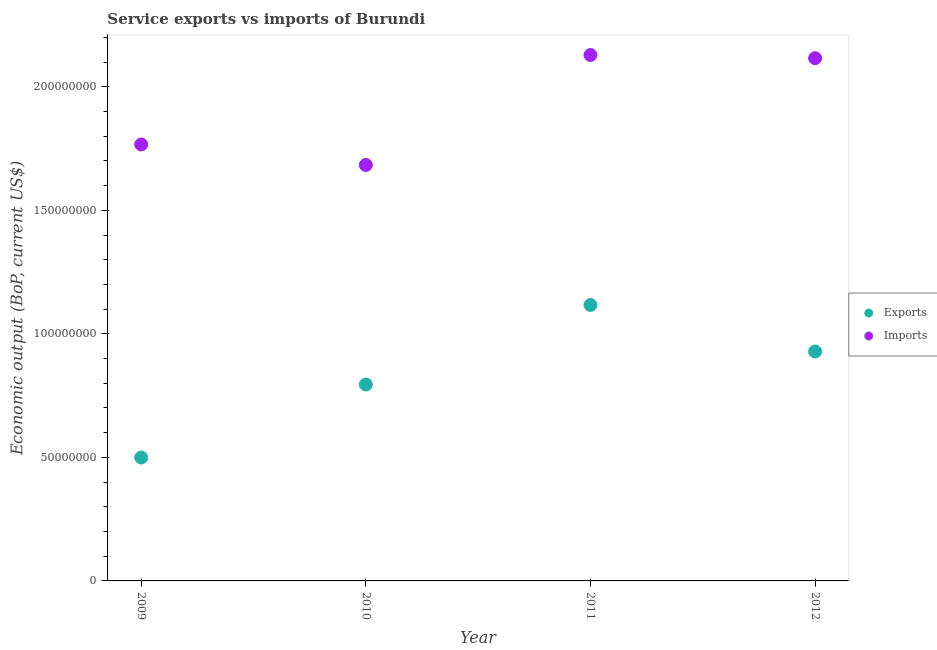How many different coloured dotlines are there?
Your answer should be very brief. 2. Is the number of dotlines equal to the number of legend labels?
Give a very brief answer. Yes. What is the amount of service imports in 2011?
Your answer should be very brief. 2.13e+08. Across all years, what is the maximum amount of service exports?
Your response must be concise. 1.12e+08. Across all years, what is the minimum amount of service imports?
Provide a short and direct response. 1.68e+08. In which year was the amount of service imports maximum?
Keep it short and to the point. 2011. What is the total amount of service imports in the graph?
Your response must be concise. 7.69e+08. What is the difference between the amount of service exports in 2010 and that in 2012?
Your answer should be compact. -1.33e+07. What is the difference between the amount of service exports in 2011 and the amount of service imports in 2012?
Offer a terse response. -9.99e+07. What is the average amount of service exports per year?
Your response must be concise. 8.35e+07. In the year 2010, what is the difference between the amount of service imports and amount of service exports?
Your answer should be very brief. 8.89e+07. What is the ratio of the amount of service exports in 2010 to that in 2011?
Offer a very short reply. 0.71. Is the amount of service exports in 2009 less than that in 2012?
Keep it short and to the point. Yes. Is the difference between the amount of service imports in 2009 and 2010 greater than the difference between the amount of service exports in 2009 and 2010?
Give a very brief answer. Yes. What is the difference between the highest and the second highest amount of service imports?
Offer a very short reply. 1.27e+06. What is the difference between the highest and the lowest amount of service imports?
Your answer should be very brief. 4.45e+07. Does the amount of service imports monotonically increase over the years?
Provide a short and direct response. No. Is the amount of service exports strictly greater than the amount of service imports over the years?
Offer a terse response. No. How many years are there in the graph?
Provide a short and direct response. 4. What is the difference between two consecutive major ticks on the Y-axis?
Make the answer very short. 5.00e+07. Does the graph contain any zero values?
Your response must be concise. No. How are the legend labels stacked?
Make the answer very short. Vertical. What is the title of the graph?
Your response must be concise. Service exports vs imports of Burundi. What is the label or title of the Y-axis?
Your response must be concise. Economic output (BoP, current US$). What is the Economic output (BoP, current US$) in Exports in 2009?
Ensure brevity in your answer.  4.99e+07. What is the Economic output (BoP, current US$) of Imports in 2009?
Offer a very short reply. 1.77e+08. What is the Economic output (BoP, current US$) in Exports in 2010?
Give a very brief answer. 7.95e+07. What is the Economic output (BoP, current US$) of Imports in 2010?
Provide a succinct answer. 1.68e+08. What is the Economic output (BoP, current US$) of Exports in 2011?
Your answer should be very brief. 1.12e+08. What is the Economic output (BoP, current US$) in Imports in 2011?
Make the answer very short. 2.13e+08. What is the Economic output (BoP, current US$) in Exports in 2012?
Your answer should be very brief. 9.28e+07. What is the Economic output (BoP, current US$) of Imports in 2012?
Offer a terse response. 2.12e+08. Across all years, what is the maximum Economic output (BoP, current US$) of Exports?
Your response must be concise. 1.12e+08. Across all years, what is the maximum Economic output (BoP, current US$) in Imports?
Your answer should be very brief. 2.13e+08. Across all years, what is the minimum Economic output (BoP, current US$) in Exports?
Make the answer very short. 4.99e+07. Across all years, what is the minimum Economic output (BoP, current US$) of Imports?
Your response must be concise. 1.68e+08. What is the total Economic output (BoP, current US$) of Exports in the graph?
Provide a succinct answer. 3.34e+08. What is the total Economic output (BoP, current US$) of Imports in the graph?
Your answer should be compact. 7.69e+08. What is the difference between the Economic output (BoP, current US$) in Exports in 2009 and that in 2010?
Your answer should be very brief. -2.96e+07. What is the difference between the Economic output (BoP, current US$) in Imports in 2009 and that in 2010?
Provide a succinct answer. 8.29e+06. What is the difference between the Economic output (BoP, current US$) in Exports in 2009 and that in 2011?
Ensure brevity in your answer.  -6.18e+07. What is the difference between the Economic output (BoP, current US$) of Imports in 2009 and that in 2011?
Your answer should be very brief. -3.62e+07. What is the difference between the Economic output (BoP, current US$) in Exports in 2009 and that in 2012?
Your answer should be compact. -4.29e+07. What is the difference between the Economic output (BoP, current US$) of Imports in 2009 and that in 2012?
Your answer should be compact. -3.49e+07. What is the difference between the Economic output (BoP, current US$) in Exports in 2010 and that in 2011?
Give a very brief answer. -3.22e+07. What is the difference between the Economic output (BoP, current US$) in Imports in 2010 and that in 2011?
Keep it short and to the point. -4.45e+07. What is the difference between the Economic output (BoP, current US$) of Exports in 2010 and that in 2012?
Ensure brevity in your answer.  -1.33e+07. What is the difference between the Economic output (BoP, current US$) of Imports in 2010 and that in 2012?
Offer a very short reply. -4.32e+07. What is the difference between the Economic output (BoP, current US$) of Exports in 2011 and that in 2012?
Your response must be concise. 1.88e+07. What is the difference between the Economic output (BoP, current US$) of Imports in 2011 and that in 2012?
Offer a terse response. 1.27e+06. What is the difference between the Economic output (BoP, current US$) of Exports in 2009 and the Economic output (BoP, current US$) of Imports in 2010?
Provide a succinct answer. -1.18e+08. What is the difference between the Economic output (BoP, current US$) of Exports in 2009 and the Economic output (BoP, current US$) of Imports in 2011?
Offer a very short reply. -1.63e+08. What is the difference between the Economic output (BoP, current US$) in Exports in 2009 and the Economic output (BoP, current US$) in Imports in 2012?
Your answer should be compact. -1.62e+08. What is the difference between the Economic output (BoP, current US$) of Exports in 2010 and the Economic output (BoP, current US$) of Imports in 2011?
Keep it short and to the point. -1.33e+08. What is the difference between the Economic output (BoP, current US$) in Exports in 2010 and the Economic output (BoP, current US$) in Imports in 2012?
Keep it short and to the point. -1.32e+08. What is the difference between the Economic output (BoP, current US$) of Exports in 2011 and the Economic output (BoP, current US$) of Imports in 2012?
Make the answer very short. -9.99e+07. What is the average Economic output (BoP, current US$) of Exports per year?
Give a very brief answer. 8.35e+07. What is the average Economic output (BoP, current US$) of Imports per year?
Ensure brevity in your answer.  1.92e+08. In the year 2009, what is the difference between the Economic output (BoP, current US$) of Exports and Economic output (BoP, current US$) of Imports?
Ensure brevity in your answer.  -1.27e+08. In the year 2010, what is the difference between the Economic output (BoP, current US$) of Exports and Economic output (BoP, current US$) of Imports?
Make the answer very short. -8.89e+07. In the year 2011, what is the difference between the Economic output (BoP, current US$) in Exports and Economic output (BoP, current US$) in Imports?
Your answer should be compact. -1.01e+08. In the year 2012, what is the difference between the Economic output (BoP, current US$) of Exports and Economic output (BoP, current US$) of Imports?
Your answer should be very brief. -1.19e+08. What is the ratio of the Economic output (BoP, current US$) of Exports in 2009 to that in 2010?
Your answer should be very brief. 0.63. What is the ratio of the Economic output (BoP, current US$) in Imports in 2009 to that in 2010?
Your answer should be very brief. 1.05. What is the ratio of the Economic output (BoP, current US$) of Exports in 2009 to that in 2011?
Ensure brevity in your answer.  0.45. What is the ratio of the Economic output (BoP, current US$) in Imports in 2009 to that in 2011?
Offer a terse response. 0.83. What is the ratio of the Economic output (BoP, current US$) in Exports in 2009 to that in 2012?
Offer a terse response. 0.54. What is the ratio of the Economic output (BoP, current US$) in Imports in 2009 to that in 2012?
Offer a terse response. 0.83. What is the ratio of the Economic output (BoP, current US$) of Exports in 2010 to that in 2011?
Your answer should be compact. 0.71. What is the ratio of the Economic output (BoP, current US$) of Imports in 2010 to that in 2011?
Provide a succinct answer. 0.79. What is the ratio of the Economic output (BoP, current US$) in Exports in 2010 to that in 2012?
Keep it short and to the point. 0.86. What is the ratio of the Economic output (BoP, current US$) of Imports in 2010 to that in 2012?
Your response must be concise. 0.8. What is the ratio of the Economic output (BoP, current US$) of Exports in 2011 to that in 2012?
Ensure brevity in your answer.  1.2. What is the difference between the highest and the second highest Economic output (BoP, current US$) of Exports?
Your answer should be compact. 1.88e+07. What is the difference between the highest and the second highest Economic output (BoP, current US$) in Imports?
Your response must be concise. 1.27e+06. What is the difference between the highest and the lowest Economic output (BoP, current US$) in Exports?
Offer a terse response. 6.18e+07. What is the difference between the highest and the lowest Economic output (BoP, current US$) in Imports?
Make the answer very short. 4.45e+07. 